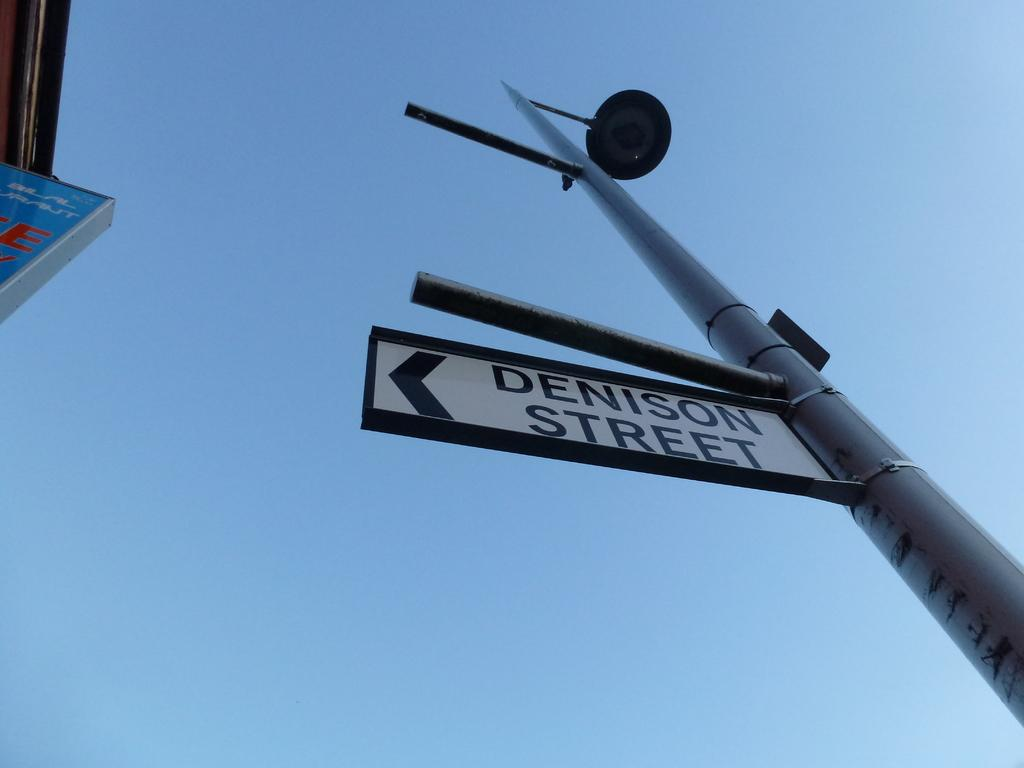<image>
Give a short and clear explanation of the subsequent image. A sign for Denison Street hangs on a post under a lamp. 